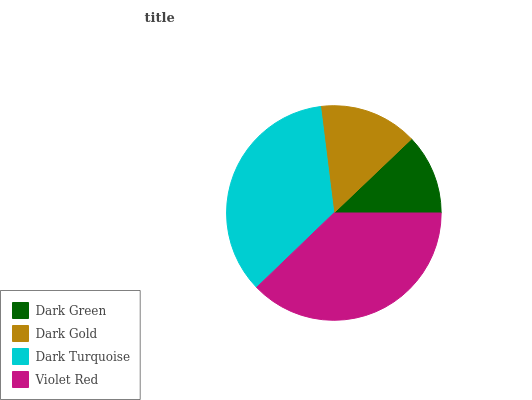Is Dark Green the minimum?
Answer yes or no. Yes. Is Violet Red the maximum?
Answer yes or no. Yes. Is Dark Gold the minimum?
Answer yes or no. No. Is Dark Gold the maximum?
Answer yes or no. No. Is Dark Gold greater than Dark Green?
Answer yes or no. Yes. Is Dark Green less than Dark Gold?
Answer yes or no. Yes. Is Dark Green greater than Dark Gold?
Answer yes or no. No. Is Dark Gold less than Dark Green?
Answer yes or no. No. Is Dark Turquoise the high median?
Answer yes or no. Yes. Is Dark Gold the low median?
Answer yes or no. Yes. Is Dark Green the high median?
Answer yes or no. No. Is Dark Turquoise the low median?
Answer yes or no. No. 